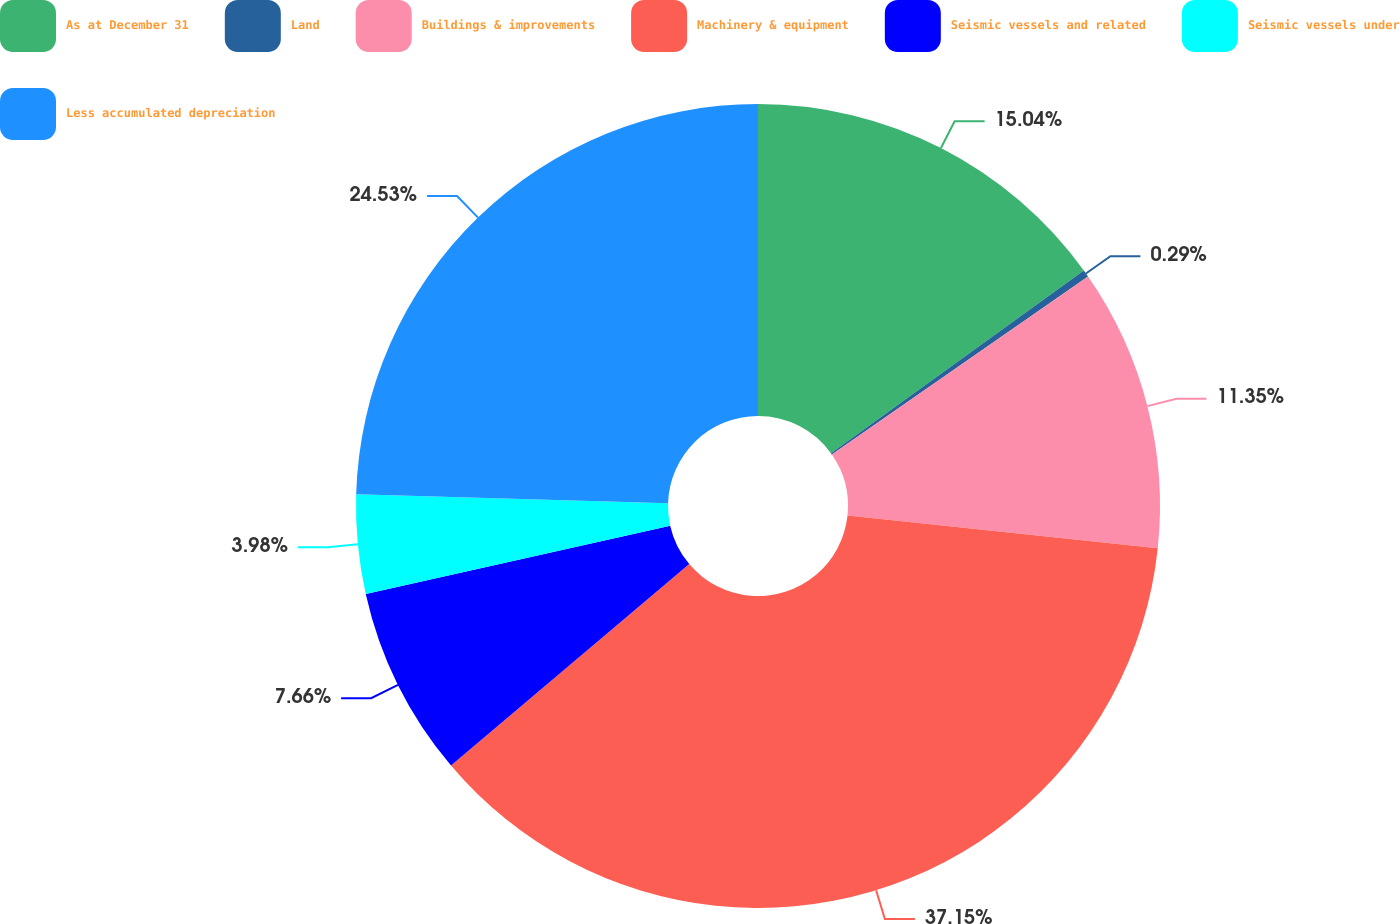Convert chart to OTSL. <chart><loc_0><loc_0><loc_500><loc_500><pie_chart><fcel>As at December 31<fcel>Land<fcel>Buildings & improvements<fcel>Machinery & equipment<fcel>Seismic vessels and related<fcel>Seismic vessels under<fcel>Less accumulated depreciation<nl><fcel>15.04%<fcel>0.29%<fcel>11.35%<fcel>37.15%<fcel>7.66%<fcel>3.98%<fcel>24.53%<nl></chart> 